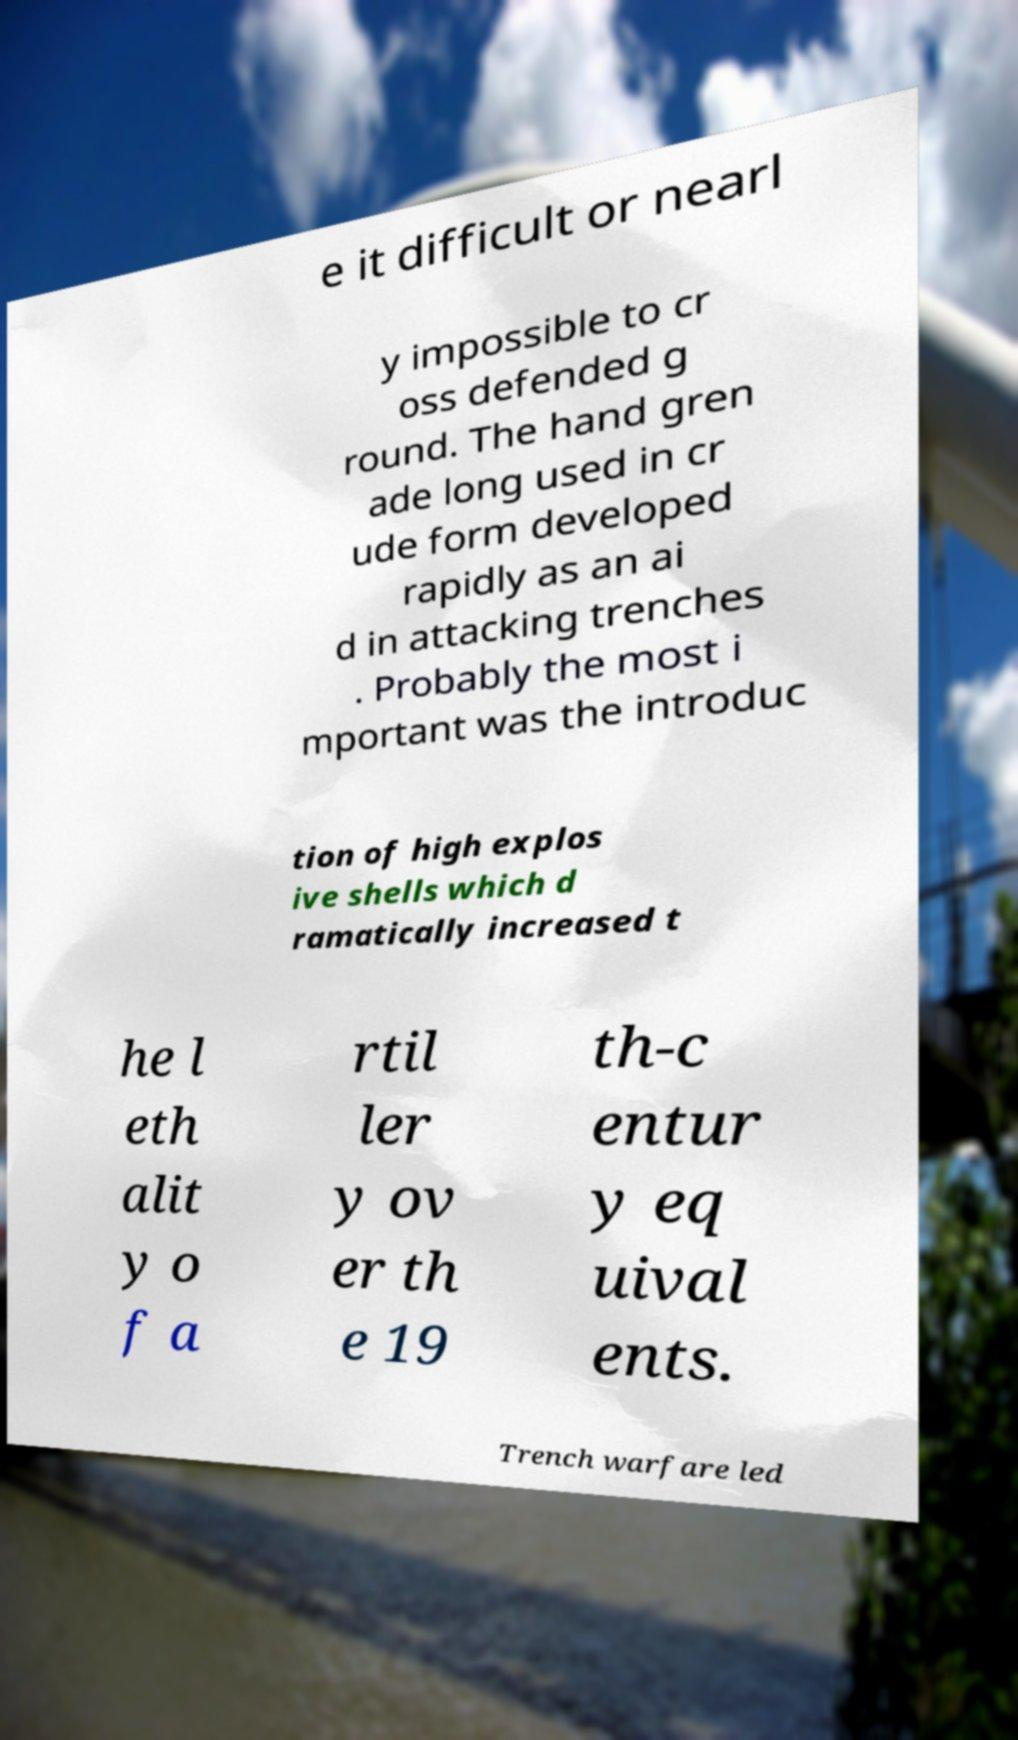Please identify and transcribe the text found in this image. e it difficult or nearl y impossible to cr oss defended g round. The hand gren ade long used in cr ude form developed rapidly as an ai d in attacking trenches . Probably the most i mportant was the introduc tion of high explos ive shells which d ramatically increased t he l eth alit y o f a rtil ler y ov er th e 19 th-c entur y eq uival ents. Trench warfare led 